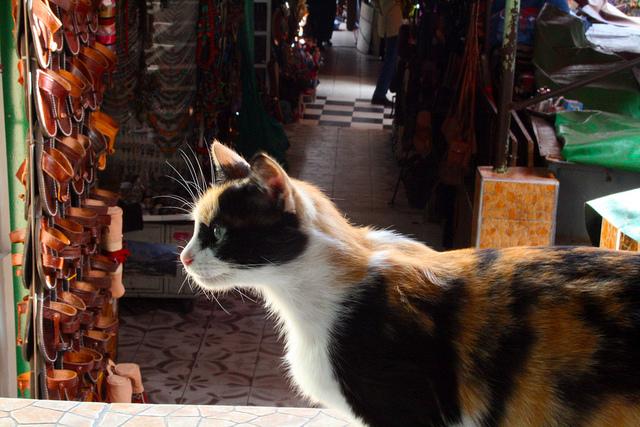What animal is in the foreground?
Give a very brief answer. Cat. What is the cat looking at?
Quick response, please. Shoes. Is the cat soft?
Answer briefly. Yes. 